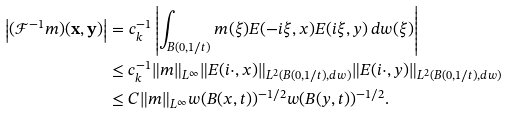Convert formula to latex. <formula><loc_0><loc_0><loc_500><loc_500>\left | ( \mathcal { F } ^ { - 1 } m ) ( \mathbf x , \mathbf y ) \right | & = c _ { k } ^ { - 1 } \left | \int _ { B ( 0 , 1 / t ) } m ( \xi ) E ( - i \xi , x ) E ( i \xi , y ) \, d w ( \xi ) \right | \\ & \leq c _ { k } ^ { - 1 } \| m \| _ { L ^ { \infty } } \| E ( i \cdot , x ) \| _ { L ^ { 2 } ( B ( 0 , 1 / t ) , d w ) } \| E ( i \cdot , y ) \| _ { L ^ { 2 } ( B ( 0 , 1 / t ) , d w ) } \\ & \leq C \| m \| _ { L ^ { \infty } } w ( B ( x , t ) ) ^ { - 1 / 2 } w ( B ( y , t ) ) ^ { - 1 / 2 } .</formula> 